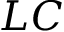Convert formula to latex. <formula><loc_0><loc_0><loc_500><loc_500>L C</formula> 